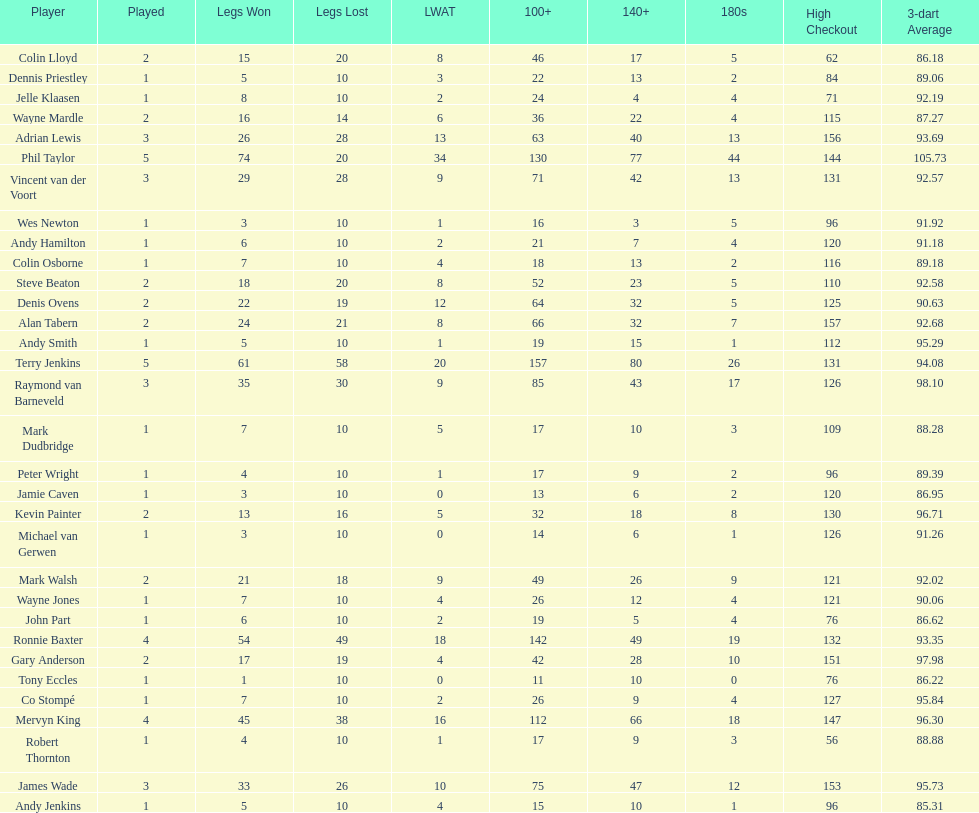What were the total number of legs won by ronnie baxter? 54. 